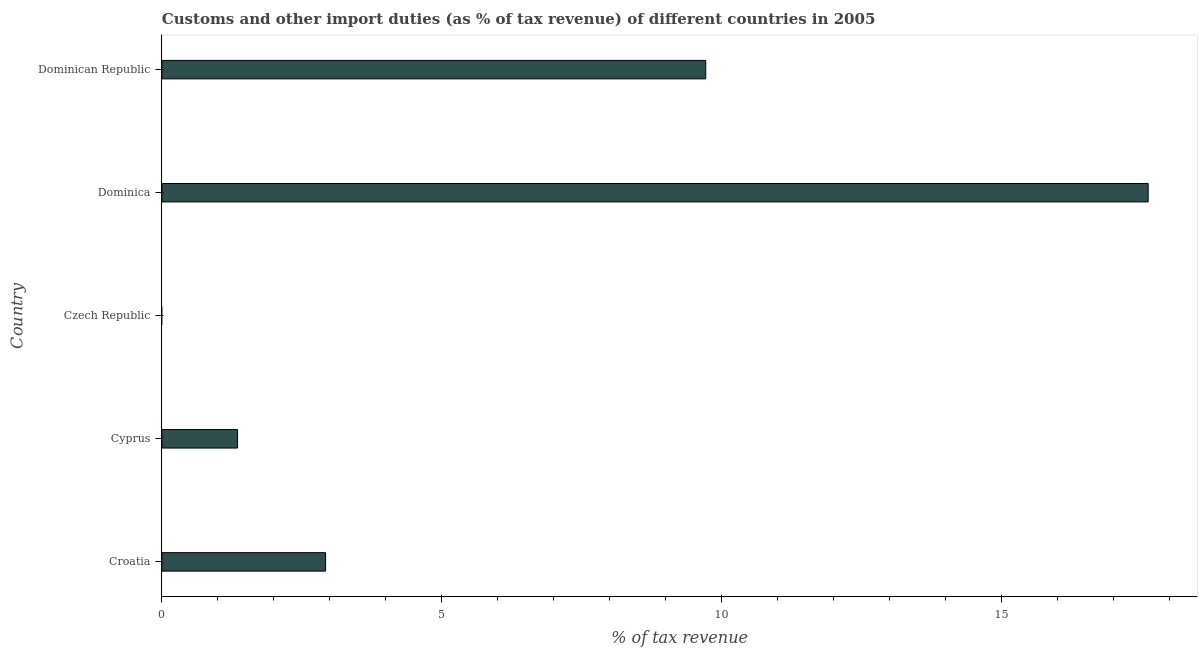What is the title of the graph?
Provide a short and direct response. Customs and other import duties (as % of tax revenue) of different countries in 2005. What is the label or title of the X-axis?
Offer a very short reply. % of tax revenue. What is the label or title of the Y-axis?
Provide a succinct answer. Country. What is the customs and other import duties in Czech Republic?
Your response must be concise. 0. Across all countries, what is the maximum customs and other import duties?
Offer a terse response. 17.62. Across all countries, what is the minimum customs and other import duties?
Provide a short and direct response. 0. In which country was the customs and other import duties maximum?
Keep it short and to the point. Dominica. What is the sum of the customs and other import duties?
Provide a short and direct response. 31.61. What is the difference between the customs and other import duties in Croatia and Dominican Republic?
Your answer should be compact. -6.79. What is the average customs and other import duties per country?
Offer a terse response. 6.32. What is the median customs and other import duties?
Keep it short and to the point. 2.92. In how many countries, is the customs and other import duties greater than 1 %?
Offer a terse response. 4. What is the ratio of the customs and other import duties in Croatia to that in Dominican Republic?
Your answer should be compact. 0.3. Is the customs and other import duties in Cyprus less than that in Dominica?
Your response must be concise. Yes. What is the difference between the highest and the second highest customs and other import duties?
Your answer should be very brief. 7.9. What is the difference between the highest and the lowest customs and other import duties?
Give a very brief answer. 17.62. How many bars are there?
Offer a very short reply. 4. What is the % of tax revenue in Croatia?
Make the answer very short. 2.92. What is the % of tax revenue of Cyprus?
Your answer should be compact. 1.35. What is the % of tax revenue in Dominica?
Provide a short and direct response. 17.62. What is the % of tax revenue of Dominican Republic?
Provide a short and direct response. 9.71. What is the difference between the % of tax revenue in Croatia and Cyprus?
Offer a terse response. 1.57. What is the difference between the % of tax revenue in Croatia and Dominica?
Your response must be concise. -14.69. What is the difference between the % of tax revenue in Croatia and Dominican Republic?
Offer a very short reply. -6.79. What is the difference between the % of tax revenue in Cyprus and Dominica?
Provide a succinct answer. -16.27. What is the difference between the % of tax revenue in Cyprus and Dominican Republic?
Your answer should be compact. -8.36. What is the difference between the % of tax revenue in Dominica and Dominican Republic?
Ensure brevity in your answer.  7.9. What is the ratio of the % of tax revenue in Croatia to that in Cyprus?
Keep it short and to the point. 2.16. What is the ratio of the % of tax revenue in Croatia to that in Dominica?
Offer a very short reply. 0.17. What is the ratio of the % of tax revenue in Croatia to that in Dominican Republic?
Provide a short and direct response. 0.3. What is the ratio of the % of tax revenue in Cyprus to that in Dominica?
Make the answer very short. 0.08. What is the ratio of the % of tax revenue in Cyprus to that in Dominican Republic?
Provide a succinct answer. 0.14. What is the ratio of the % of tax revenue in Dominica to that in Dominican Republic?
Your response must be concise. 1.81. 